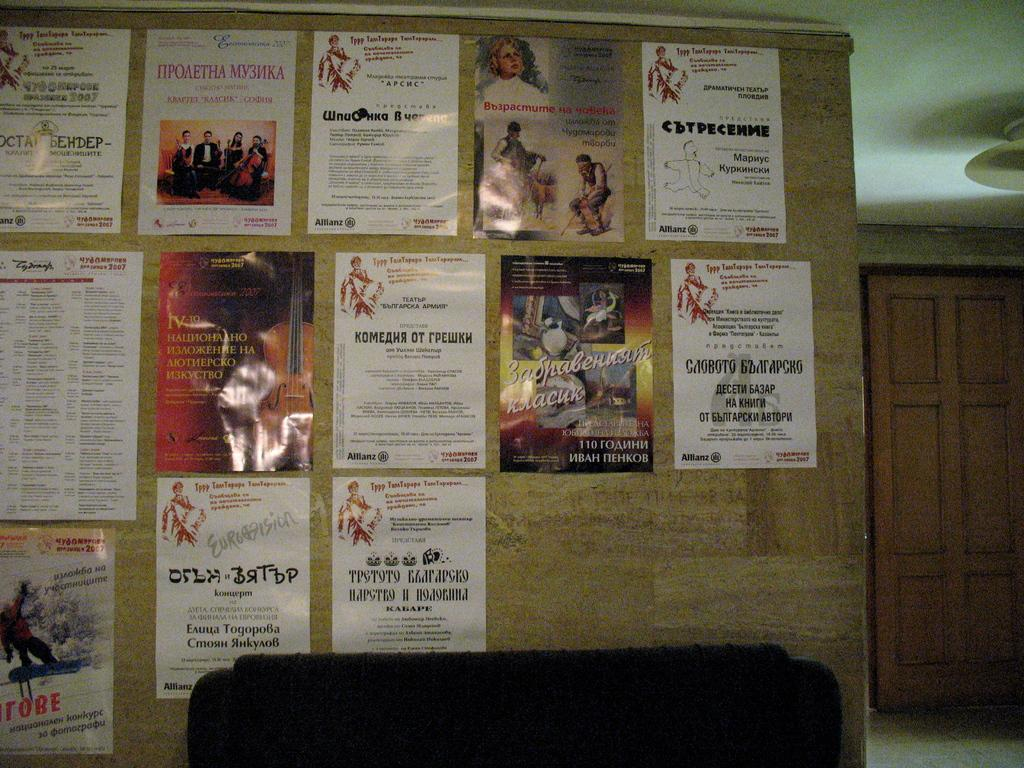<image>
Create a compact narrative representing the image presented. Some posters on a board with foreign lettering, the letters KOME are visible. 